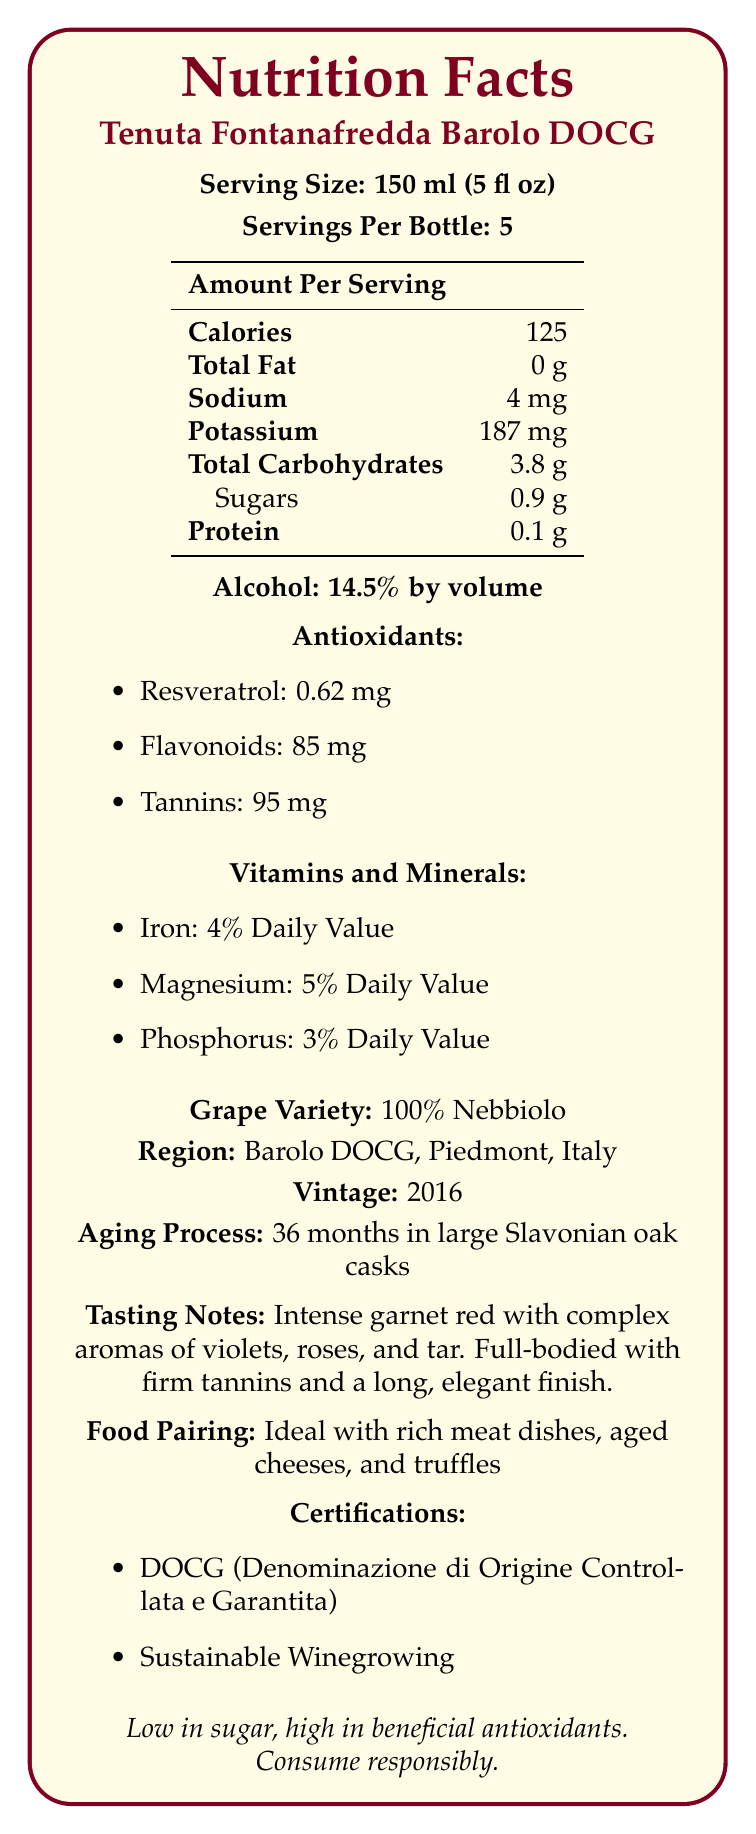what is the serving size? The document specifies the serving size as "150 ml (5 fl oz)".
Answer: 150 ml (5 fl oz) how many calories are there per serving? The document lists "Calories: 125" under the nutritional information.
Answer: 125 how much sugar does one serving contain? The document specifies the sugar content as "Sugars: 0.9 g" under the total carbohydrates section.
Answer: 0.9 g what is the alcohol content by volume? The document lists "Alcohol: 14.5% by volume".
Answer: 14.5% which antioxidants are present and in what amounts? The document under the antioxidants section lists "Resveratrol: 0.62 mg", "Flavonoids: 85 mg", and "Tannins: 95 mg".
Answer: Resveratrol: 0.62 mg, Flavonoids: 85 mg, Tannins: 95 mg what is the potassium content per serving? The document specifies "Potassium: 187 mg" under the nutritional information.
Answer: 187 mg how long is the aging process for this wine? The document states "Aging Process: 36 months in large Slavonian oak casks".
Answer: 36 months in large Slavonian oak casks what is the grape variety used for this wine? The document indicates "Grape Variety: 100% Nebbiolo".
Answer: 100% Nebbiolo which of the following certifications does the wine have? A. Organic B. DOCG C. Eco-friendly The document lists "DOCG (Denominazione di Origine Controllata e Garantita)" under the certifications section.
Answer: B. DOCG which region is this wine from? A. Napa Valley B. Bordeaux C. Barolo DOCG The document specifies the region as "Barolo DOCG, Piedmont, Italy".
Answer: C. Barolo DOCG is the wine low in sugar? The document mentions "low in sugar" in the additional information section.
Answer: Yes summarize the main features of the Tenuta Fontanafredda Barolo DOCG wine. This summary encompasses the primary details provided in the document about the wine, including its nutritional information, ingredients, aging process, tasting notes, food pairing suggestions, and certifications.
Answer: The Tenuta Fontanafredda Barolo DOCG wine is a premium product from Piedmont, Italy, with a serving size of 150 ml. It has 125 calories per serving, 0.9 g of sugars, and 14.5% alcohol by volume. The wine is rich in antioxidants like resveratrol (0.62 mg), flavonoids (85 mg), and tannins (95 mg). Made from 100% Nebbiolo grapes, it has gone through an aging process of 36 months in large Slavonian oak casks. It features intense garnet red color and offers complex aromas of violets, roses, and tar. The wine pairs well with rich meat dishes, aged cheeses, and truffles, and holds certifications like DOCG and Sustainable Winegrowing. how much protein does one serving provide? The document lists "Protein: 0.1 g" under the nutritional information.
Answer: 0.1 g what percentage of the daily value for iron does one serving of this wine contain? The document specifies "Iron: 4% Daily Value" under the vitamins and minerals section.
Answer: 4% what are the tasting notes for this wine? The document includes detailed tasting notes describing the wine's appearance, aroma, and taste.
Answer: Intense garnet red with complex aromas of violets, roses, and tar. Full-bodied with firm tannins and a long, elegant finish. how many servings are there per bottle? The document states "Servings Per Bottle: 5".
Answer: 5 what is the food pairing recommendation for this wine? The document suggests that the wine is "Ideal with rich meat dishes, aged cheeses, and truffles".
Answer: Rich meat dishes, aged cheeses, and truffles does the document mention the specific vineyard where the wine is produced? The document does not explicitly mention a specific vineyard; it only provides general information such as the region (Barolo DOCG, Piedmont, Italy).
Answer: Cannot be determined 